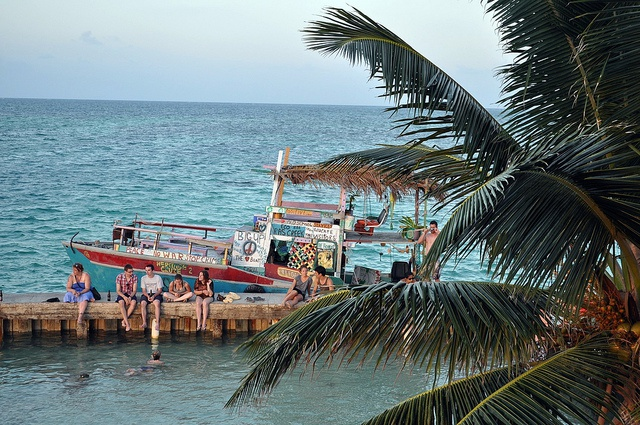Describe the objects in this image and their specific colors. I can see boat in lightblue, darkgray, gray, and teal tones, boat in lightblue, darkgray, gray, brown, and black tones, people in lightblue, brown, salmon, blue, and gray tones, people in lightblue, black, gray, lightpink, and brown tones, and people in lightblue, gray, lightpink, lightgray, and darkgray tones in this image. 